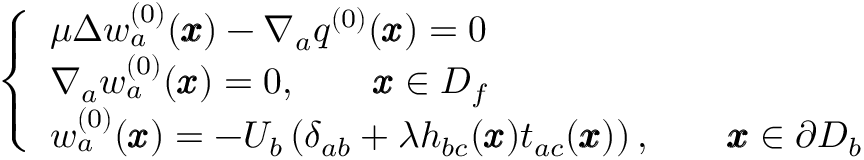<formula> <loc_0><loc_0><loc_500><loc_500>\left \{ \begin{array} { l l } { \mu \Delta w _ { a } ^ { ( 0 ) } ( { \pm b x } ) - \nabla _ { a } q ^ { ( 0 ) } ( { \pm b x } ) = 0 } \\ { \nabla _ { a } w _ { a } ^ { ( 0 ) } ( { \pm b x } ) = 0 , \quad { \pm b x } \in D _ { f } } \\ { w _ { a } ^ { ( 0 ) } ( \pm b x ) = - U _ { b } \left ( \delta _ { a b } + { \lambda } h _ { b c } ( { \pm b x } ) t _ { a c } ( { \pm b x } ) \right ) , \quad { \pm b x } \in \partial D _ { b } } \end{array}</formula> 